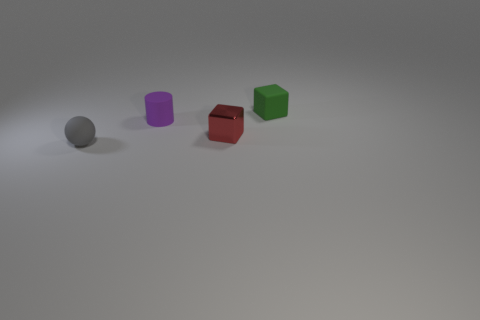Add 3 green matte objects. How many objects exist? 7 Subtract all spheres. How many objects are left? 3 Add 1 big spheres. How many big spheres exist? 1 Subtract 0 yellow cubes. How many objects are left? 4 Subtract all cylinders. Subtract all gray objects. How many objects are left? 2 Add 4 tiny spheres. How many tiny spheres are left? 5 